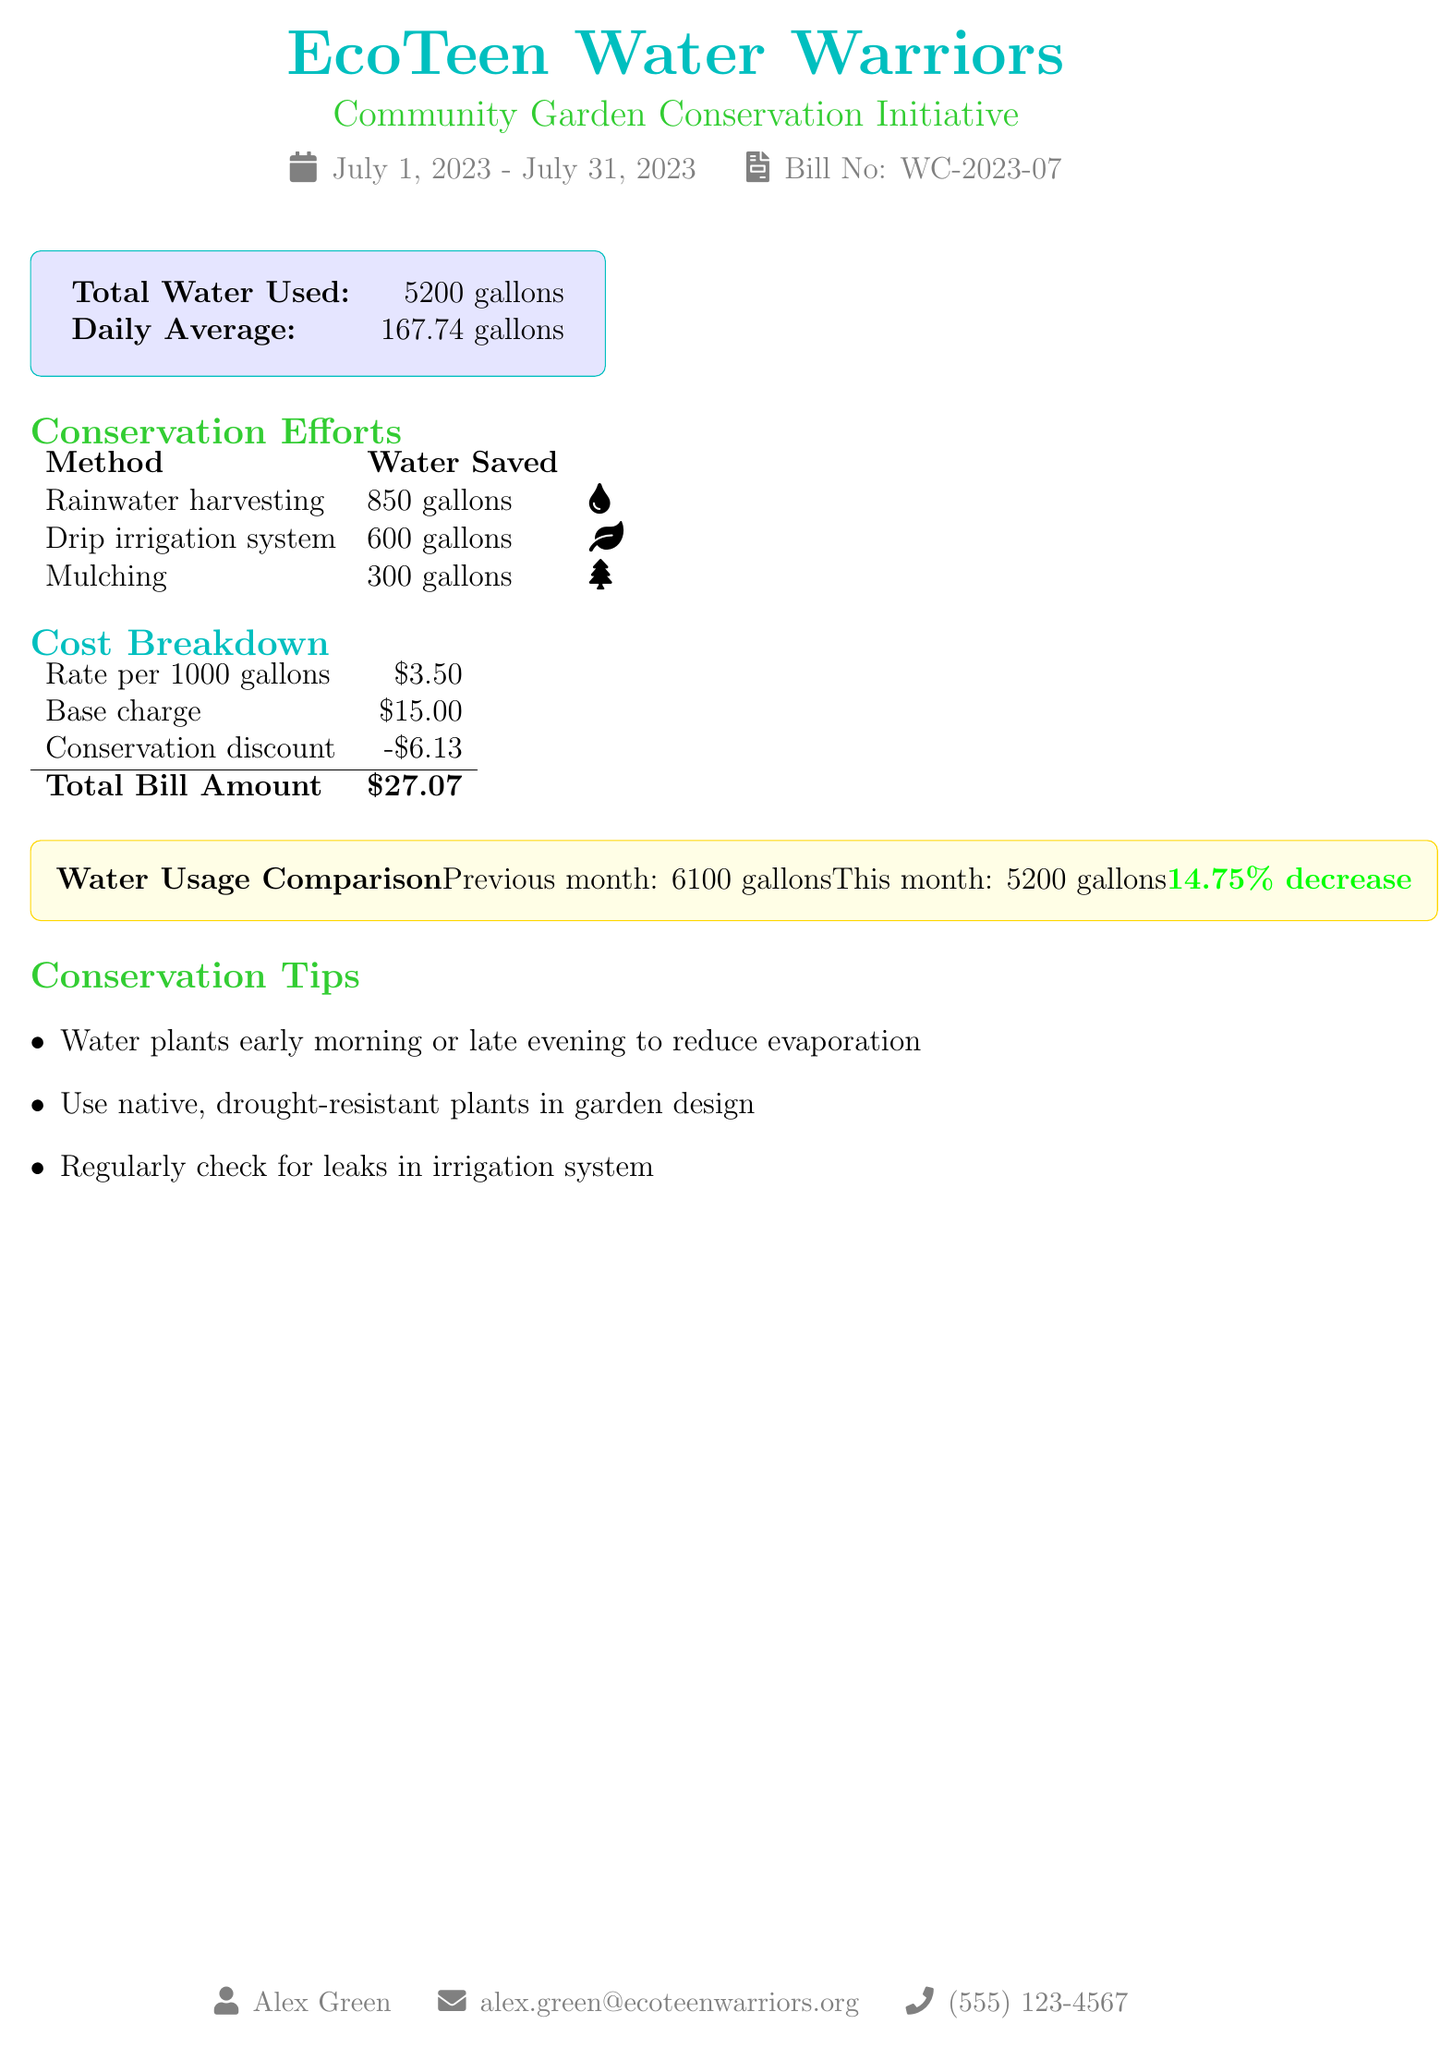What is the total water used? The total water used is shown in the document as part of the water usage information.
Answer: 5200 gallons What is the daily average water usage? The daily average is calculated based on the total water used within the provided time frame.
Answer: 167.74 gallons How much water did rainwater harvesting save? The document lists the amount of water saved through rainwater harvesting.
Answer: 850 gallons What is the total bill amount? The total bill amount is provided under the cost breakdown section of the document.
Answer: $27.07 What was the water usage in the previous month? The document provides a comparison of water usage between the previous month and the current month.
Answer: 6100 gallons What is the percentage decrease in water usage? The percentage decrease is calculated based on the comparison of water usage between months, as stated in the document.
Answer: 14.75% What conservation discount was applied to the bill? The document indicates the amount that was discounted for conservation efforts.
Answer: -$6.13 What method saved the least amount of water? The methods of conservation listed in the document have varying amounts saved, identifying the least savings directly.
Answer: Mulching Who is the contact person mentioned in the document? The document provides a contact person for inquiries related to the bill.
Answer: Alex Green 